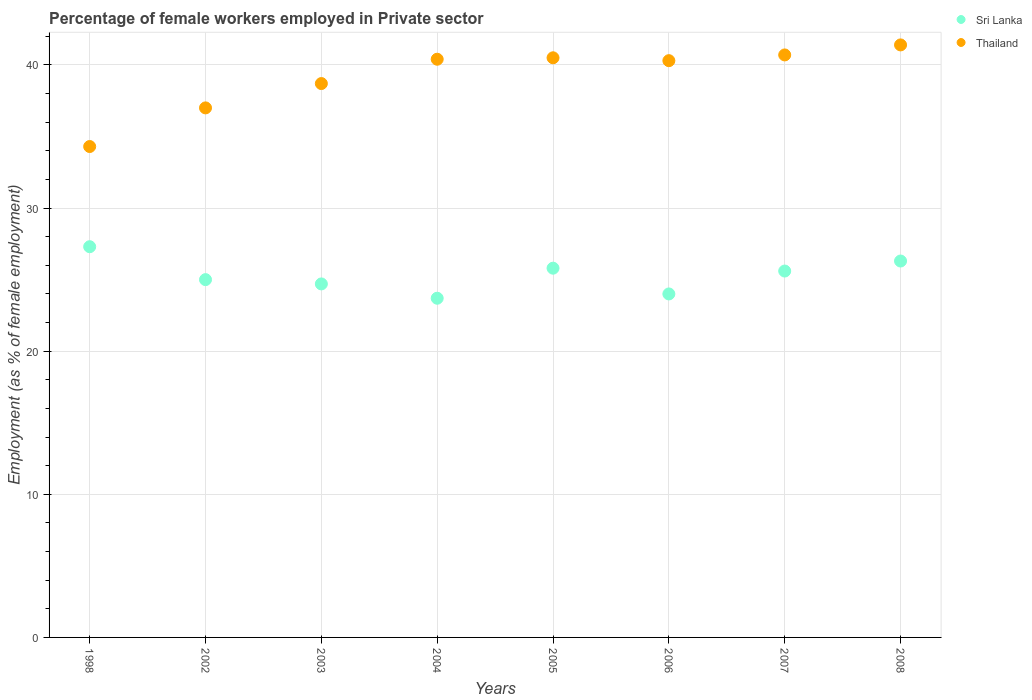What is the percentage of females employed in Private sector in Thailand in 2007?
Your response must be concise. 40.7. Across all years, what is the maximum percentage of females employed in Private sector in Sri Lanka?
Your answer should be compact. 27.3. Across all years, what is the minimum percentage of females employed in Private sector in Sri Lanka?
Your response must be concise. 23.7. In which year was the percentage of females employed in Private sector in Sri Lanka maximum?
Make the answer very short. 1998. What is the total percentage of females employed in Private sector in Sri Lanka in the graph?
Provide a short and direct response. 202.4. What is the difference between the percentage of females employed in Private sector in Thailand in 2006 and the percentage of females employed in Private sector in Sri Lanka in 2004?
Keep it short and to the point. 16.6. What is the average percentage of females employed in Private sector in Thailand per year?
Your response must be concise. 39.16. In the year 2006, what is the difference between the percentage of females employed in Private sector in Thailand and percentage of females employed in Private sector in Sri Lanka?
Ensure brevity in your answer.  16.3. In how many years, is the percentage of females employed in Private sector in Sri Lanka greater than 30 %?
Keep it short and to the point. 0. What is the ratio of the percentage of females employed in Private sector in Sri Lanka in 2002 to that in 2008?
Give a very brief answer. 0.95. Is the difference between the percentage of females employed in Private sector in Thailand in 2004 and 2008 greater than the difference between the percentage of females employed in Private sector in Sri Lanka in 2004 and 2008?
Your answer should be very brief. Yes. What is the difference between the highest and the second highest percentage of females employed in Private sector in Thailand?
Offer a terse response. 0.7. What is the difference between the highest and the lowest percentage of females employed in Private sector in Thailand?
Offer a very short reply. 7.1. In how many years, is the percentage of females employed in Private sector in Sri Lanka greater than the average percentage of females employed in Private sector in Sri Lanka taken over all years?
Your answer should be compact. 4. Is the sum of the percentage of females employed in Private sector in Thailand in 2005 and 2008 greater than the maximum percentage of females employed in Private sector in Sri Lanka across all years?
Offer a terse response. Yes. Is the percentage of females employed in Private sector in Sri Lanka strictly less than the percentage of females employed in Private sector in Thailand over the years?
Your response must be concise. Yes. What is the difference between two consecutive major ticks on the Y-axis?
Keep it short and to the point. 10. Are the values on the major ticks of Y-axis written in scientific E-notation?
Provide a succinct answer. No. Does the graph contain any zero values?
Offer a terse response. No. Does the graph contain grids?
Provide a succinct answer. Yes. How many legend labels are there?
Give a very brief answer. 2. How are the legend labels stacked?
Your answer should be very brief. Vertical. What is the title of the graph?
Your answer should be compact. Percentage of female workers employed in Private sector. Does "Zambia" appear as one of the legend labels in the graph?
Give a very brief answer. No. What is the label or title of the Y-axis?
Ensure brevity in your answer.  Employment (as % of female employment). What is the Employment (as % of female employment) of Sri Lanka in 1998?
Your answer should be compact. 27.3. What is the Employment (as % of female employment) in Thailand in 1998?
Your answer should be compact. 34.3. What is the Employment (as % of female employment) in Sri Lanka in 2003?
Your answer should be compact. 24.7. What is the Employment (as % of female employment) of Thailand in 2003?
Your response must be concise. 38.7. What is the Employment (as % of female employment) of Sri Lanka in 2004?
Provide a succinct answer. 23.7. What is the Employment (as % of female employment) in Thailand in 2004?
Your answer should be compact. 40.4. What is the Employment (as % of female employment) of Sri Lanka in 2005?
Ensure brevity in your answer.  25.8. What is the Employment (as % of female employment) in Thailand in 2005?
Make the answer very short. 40.5. What is the Employment (as % of female employment) of Thailand in 2006?
Offer a terse response. 40.3. What is the Employment (as % of female employment) in Sri Lanka in 2007?
Provide a short and direct response. 25.6. What is the Employment (as % of female employment) in Thailand in 2007?
Provide a succinct answer. 40.7. What is the Employment (as % of female employment) of Sri Lanka in 2008?
Offer a very short reply. 26.3. What is the Employment (as % of female employment) of Thailand in 2008?
Keep it short and to the point. 41.4. Across all years, what is the maximum Employment (as % of female employment) in Sri Lanka?
Your answer should be very brief. 27.3. Across all years, what is the maximum Employment (as % of female employment) of Thailand?
Ensure brevity in your answer.  41.4. Across all years, what is the minimum Employment (as % of female employment) of Sri Lanka?
Ensure brevity in your answer.  23.7. Across all years, what is the minimum Employment (as % of female employment) of Thailand?
Keep it short and to the point. 34.3. What is the total Employment (as % of female employment) in Sri Lanka in the graph?
Keep it short and to the point. 202.4. What is the total Employment (as % of female employment) of Thailand in the graph?
Ensure brevity in your answer.  313.3. What is the difference between the Employment (as % of female employment) in Sri Lanka in 1998 and that in 2004?
Offer a terse response. 3.6. What is the difference between the Employment (as % of female employment) of Thailand in 1998 and that in 2005?
Offer a very short reply. -6.2. What is the difference between the Employment (as % of female employment) in Sri Lanka in 1998 and that in 2006?
Make the answer very short. 3.3. What is the difference between the Employment (as % of female employment) of Thailand in 1998 and that in 2006?
Offer a very short reply. -6. What is the difference between the Employment (as % of female employment) in Sri Lanka in 1998 and that in 2007?
Make the answer very short. 1.7. What is the difference between the Employment (as % of female employment) in Thailand in 1998 and that in 2007?
Provide a succinct answer. -6.4. What is the difference between the Employment (as % of female employment) of Thailand in 1998 and that in 2008?
Give a very brief answer. -7.1. What is the difference between the Employment (as % of female employment) in Sri Lanka in 2002 and that in 2003?
Offer a very short reply. 0.3. What is the difference between the Employment (as % of female employment) in Thailand in 2002 and that in 2004?
Your answer should be compact. -3.4. What is the difference between the Employment (as % of female employment) of Sri Lanka in 2002 and that in 2006?
Keep it short and to the point. 1. What is the difference between the Employment (as % of female employment) of Thailand in 2002 and that in 2006?
Your answer should be very brief. -3.3. What is the difference between the Employment (as % of female employment) of Thailand in 2002 and that in 2007?
Offer a very short reply. -3.7. What is the difference between the Employment (as % of female employment) of Thailand in 2002 and that in 2008?
Make the answer very short. -4.4. What is the difference between the Employment (as % of female employment) of Sri Lanka in 2003 and that in 2004?
Make the answer very short. 1. What is the difference between the Employment (as % of female employment) in Sri Lanka in 2003 and that in 2006?
Offer a very short reply. 0.7. What is the difference between the Employment (as % of female employment) of Sri Lanka in 2003 and that in 2007?
Offer a very short reply. -0.9. What is the difference between the Employment (as % of female employment) of Thailand in 2003 and that in 2008?
Ensure brevity in your answer.  -2.7. What is the difference between the Employment (as % of female employment) of Sri Lanka in 2004 and that in 2005?
Your response must be concise. -2.1. What is the difference between the Employment (as % of female employment) of Thailand in 2004 and that in 2005?
Ensure brevity in your answer.  -0.1. What is the difference between the Employment (as % of female employment) in Thailand in 2004 and that in 2006?
Offer a terse response. 0.1. What is the difference between the Employment (as % of female employment) of Thailand in 2005 and that in 2006?
Keep it short and to the point. 0.2. What is the difference between the Employment (as % of female employment) of Sri Lanka in 2005 and that in 2007?
Make the answer very short. 0.2. What is the difference between the Employment (as % of female employment) of Sri Lanka in 2005 and that in 2008?
Your answer should be very brief. -0.5. What is the difference between the Employment (as % of female employment) in Thailand in 2005 and that in 2008?
Provide a short and direct response. -0.9. What is the difference between the Employment (as % of female employment) in Thailand in 2006 and that in 2007?
Your answer should be compact. -0.4. What is the difference between the Employment (as % of female employment) of Sri Lanka in 1998 and the Employment (as % of female employment) of Thailand in 2002?
Provide a short and direct response. -9.7. What is the difference between the Employment (as % of female employment) in Sri Lanka in 1998 and the Employment (as % of female employment) in Thailand in 2003?
Offer a very short reply. -11.4. What is the difference between the Employment (as % of female employment) in Sri Lanka in 1998 and the Employment (as % of female employment) in Thailand in 2004?
Keep it short and to the point. -13.1. What is the difference between the Employment (as % of female employment) of Sri Lanka in 1998 and the Employment (as % of female employment) of Thailand in 2008?
Provide a succinct answer. -14.1. What is the difference between the Employment (as % of female employment) in Sri Lanka in 2002 and the Employment (as % of female employment) in Thailand in 2003?
Keep it short and to the point. -13.7. What is the difference between the Employment (as % of female employment) of Sri Lanka in 2002 and the Employment (as % of female employment) of Thailand in 2004?
Provide a succinct answer. -15.4. What is the difference between the Employment (as % of female employment) of Sri Lanka in 2002 and the Employment (as % of female employment) of Thailand in 2005?
Ensure brevity in your answer.  -15.5. What is the difference between the Employment (as % of female employment) in Sri Lanka in 2002 and the Employment (as % of female employment) in Thailand in 2006?
Offer a very short reply. -15.3. What is the difference between the Employment (as % of female employment) in Sri Lanka in 2002 and the Employment (as % of female employment) in Thailand in 2007?
Ensure brevity in your answer.  -15.7. What is the difference between the Employment (as % of female employment) in Sri Lanka in 2002 and the Employment (as % of female employment) in Thailand in 2008?
Provide a succinct answer. -16.4. What is the difference between the Employment (as % of female employment) in Sri Lanka in 2003 and the Employment (as % of female employment) in Thailand in 2004?
Your answer should be compact. -15.7. What is the difference between the Employment (as % of female employment) in Sri Lanka in 2003 and the Employment (as % of female employment) in Thailand in 2005?
Your answer should be compact. -15.8. What is the difference between the Employment (as % of female employment) of Sri Lanka in 2003 and the Employment (as % of female employment) of Thailand in 2006?
Make the answer very short. -15.6. What is the difference between the Employment (as % of female employment) of Sri Lanka in 2003 and the Employment (as % of female employment) of Thailand in 2008?
Offer a very short reply. -16.7. What is the difference between the Employment (as % of female employment) of Sri Lanka in 2004 and the Employment (as % of female employment) of Thailand in 2005?
Provide a succinct answer. -16.8. What is the difference between the Employment (as % of female employment) in Sri Lanka in 2004 and the Employment (as % of female employment) in Thailand in 2006?
Your response must be concise. -16.6. What is the difference between the Employment (as % of female employment) of Sri Lanka in 2004 and the Employment (as % of female employment) of Thailand in 2008?
Offer a very short reply. -17.7. What is the difference between the Employment (as % of female employment) in Sri Lanka in 2005 and the Employment (as % of female employment) in Thailand in 2006?
Your answer should be very brief. -14.5. What is the difference between the Employment (as % of female employment) in Sri Lanka in 2005 and the Employment (as % of female employment) in Thailand in 2007?
Provide a succinct answer. -14.9. What is the difference between the Employment (as % of female employment) in Sri Lanka in 2005 and the Employment (as % of female employment) in Thailand in 2008?
Provide a succinct answer. -15.6. What is the difference between the Employment (as % of female employment) of Sri Lanka in 2006 and the Employment (as % of female employment) of Thailand in 2007?
Make the answer very short. -16.7. What is the difference between the Employment (as % of female employment) in Sri Lanka in 2006 and the Employment (as % of female employment) in Thailand in 2008?
Make the answer very short. -17.4. What is the difference between the Employment (as % of female employment) of Sri Lanka in 2007 and the Employment (as % of female employment) of Thailand in 2008?
Your answer should be compact. -15.8. What is the average Employment (as % of female employment) in Sri Lanka per year?
Provide a succinct answer. 25.3. What is the average Employment (as % of female employment) of Thailand per year?
Offer a terse response. 39.16. In the year 1998, what is the difference between the Employment (as % of female employment) of Sri Lanka and Employment (as % of female employment) of Thailand?
Your answer should be very brief. -7. In the year 2002, what is the difference between the Employment (as % of female employment) in Sri Lanka and Employment (as % of female employment) in Thailand?
Give a very brief answer. -12. In the year 2004, what is the difference between the Employment (as % of female employment) of Sri Lanka and Employment (as % of female employment) of Thailand?
Ensure brevity in your answer.  -16.7. In the year 2005, what is the difference between the Employment (as % of female employment) in Sri Lanka and Employment (as % of female employment) in Thailand?
Your response must be concise. -14.7. In the year 2006, what is the difference between the Employment (as % of female employment) of Sri Lanka and Employment (as % of female employment) of Thailand?
Ensure brevity in your answer.  -16.3. In the year 2007, what is the difference between the Employment (as % of female employment) of Sri Lanka and Employment (as % of female employment) of Thailand?
Your response must be concise. -15.1. In the year 2008, what is the difference between the Employment (as % of female employment) in Sri Lanka and Employment (as % of female employment) in Thailand?
Make the answer very short. -15.1. What is the ratio of the Employment (as % of female employment) of Sri Lanka in 1998 to that in 2002?
Keep it short and to the point. 1.09. What is the ratio of the Employment (as % of female employment) in Thailand in 1998 to that in 2002?
Your response must be concise. 0.93. What is the ratio of the Employment (as % of female employment) in Sri Lanka in 1998 to that in 2003?
Keep it short and to the point. 1.11. What is the ratio of the Employment (as % of female employment) of Thailand in 1998 to that in 2003?
Ensure brevity in your answer.  0.89. What is the ratio of the Employment (as % of female employment) in Sri Lanka in 1998 to that in 2004?
Offer a terse response. 1.15. What is the ratio of the Employment (as % of female employment) in Thailand in 1998 to that in 2004?
Make the answer very short. 0.85. What is the ratio of the Employment (as % of female employment) of Sri Lanka in 1998 to that in 2005?
Keep it short and to the point. 1.06. What is the ratio of the Employment (as % of female employment) in Thailand in 1998 to that in 2005?
Ensure brevity in your answer.  0.85. What is the ratio of the Employment (as % of female employment) in Sri Lanka in 1998 to that in 2006?
Ensure brevity in your answer.  1.14. What is the ratio of the Employment (as % of female employment) of Thailand in 1998 to that in 2006?
Give a very brief answer. 0.85. What is the ratio of the Employment (as % of female employment) in Sri Lanka in 1998 to that in 2007?
Ensure brevity in your answer.  1.07. What is the ratio of the Employment (as % of female employment) of Thailand in 1998 to that in 2007?
Your response must be concise. 0.84. What is the ratio of the Employment (as % of female employment) in Sri Lanka in 1998 to that in 2008?
Give a very brief answer. 1.04. What is the ratio of the Employment (as % of female employment) in Thailand in 1998 to that in 2008?
Your answer should be compact. 0.83. What is the ratio of the Employment (as % of female employment) of Sri Lanka in 2002 to that in 2003?
Give a very brief answer. 1.01. What is the ratio of the Employment (as % of female employment) of Thailand in 2002 to that in 2003?
Give a very brief answer. 0.96. What is the ratio of the Employment (as % of female employment) in Sri Lanka in 2002 to that in 2004?
Offer a terse response. 1.05. What is the ratio of the Employment (as % of female employment) of Thailand in 2002 to that in 2004?
Your response must be concise. 0.92. What is the ratio of the Employment (as % of female employment) of Thailand in 2002 to that in 2005?
Make the answer very short. 0.91. What is the ratio of the Employment (as % of female employment) of Sri Lanka in 2002 to that in 2006?
Make the answer very short. 1.04. What is the ratio of the Employment (as % of female employment) of Thailand in 2002 to that in 2006?
Your response must be concise. 0.92. What is the ratio of the Employment (as % of female employment) in Sri Lanka in 2002 to that in 2007?
Offer a very short reply. 0.98. What is the ratio of the Employment (as % of female employment) in Sri Lanka in 2002 to that in 2008?
Provide a succinct answer. 0.95. What is the ratio of the Employment (as % of female employment) in Thailand in 2002 to that in 2008?
Provide a succinct answer. 0.89. What is the ratio of the Employment (as % of female employment) in Sri Lanka in 2003 to that in 2004?
Ensure brevity in your answer.  1.04. What is the ratio of the Employment (as % of female employment) of Thailand in 2003 to that in 2004?
Offer a terse response. 0.96. What is the ratio of the Employment (as % of female employment) of Sri Lanka in 2003 to that in 2005?
Provide a succinct answer. 0.96. What is the ratio of the Employment (as % of female employment) of Thailand in 2003 to that in 2005?
Your answer should be compact. 0.96. What is the ratio of the Employment (as % of female employment) in Sri Lanka in 2003 to that in 2006?
Give a very brief answer. 1.03. What is the ratio of the Employment (as % of female employment) in Thailand in 2003 to that in 2006?
Your response must be concise. 0.96. What is the ratio of the Employment (as % of female employment) in Sri Lanka in 2003 to that in 2007?
Your response must be concise. 0.96. What is the ratio of the Employment (as % of female employment) of Thailand in 2003 to that in 2007?
Provide a short and direct response. 0.95. What is the ratio of the Employment (as % of female employment) of Sri Lanka in 2003 to that in 2008?
Provide a short and direct response. 0.94. What is the ratio of the Employment (as % of female employment) in Thailand in 2003 to that in 2008?
Offer a very short reply. 0.93. What is the ratio of the Employment (as % of female employment) of Sri Lanka in 2004 to that in 2005?
Provide a short and direct response. 0.92. What is the ratio of the Employment (as % of female employment) of Thailand in 2004 to that in 2005?
Keep it short and to the point. 1. What is the ratio of the Employment (as % of female employment) of Sri Lanka in 2004 to that in 2006?
Keep it short and to the point. 0.99. What is the ratio of the Employment (as % of female employment) of Sri Lanka in 2004 to that in 2007?
Provide a succinct answer. 0.93. What is the ratio of the Employment (as % of female employment) in Sri Lanka in 2004 to that in 2008?
Offer a very short reply. 0.9. What is the ratio of the Employment (as % of female employment) in Thailand in 2004 to that in 2008?
Your answer should be very brief. 0.98. What is the ratio of the Employment (as % of female employment) in Sri Lanka in 2005 to that in 2006?
Provide a succinct answer. 1.07. What is the ratio of the Employment (as % of female employment) in Thailand in 2005 to that in 2006?
Ensure brevity in your answer.  1. What is the ratio of the Employment (as % of female employment) of Sri Lanka in 2005 to that in 2007?
Keep it short and to the point. 1.01. What is the ratio of the Employment (as % of female employment) in Thailand in 2005 to that in 2007?
Your answer should be very brief. 1. What is the ratio of the Employment (as % of female employment) in Sri Lanka in 2005 to that in 2008?
Your answer should be very brief. 0.98. What is the ratio of the Employment (as % of female employment) in Thailand in 2005 to that in 2008?
Offer a very short reply. 0.98. What is the ratio of the Employment (as % of female employment) in Thailand in 2006 to that in 2007?
Provide a short and direct response. 0.99. What is the ratio of the Employment (as % of female employment) in Sri Lanka in 2006 to that in 2008?
Ensure brevity in your answer.  0.91. What is the ratio of the Employment (as % of female employment) in Thailand in 2006 to that in 2008?
Ensure brevity in your answer.  0.97. What is the ratio of the Employment (as % of female employment) of Sri Lanka in 2007 to that in 2008?
Offer a very short reply. 0.97. What is the ratio of the Employment (as % of female employment) in Thailand in 2007 to that in 2008?
Your response must be concise. 0.98. What is the difference between the highest and the second highest Employment (as % of female employment) in Thailand?
Keep it short and to the point. 0.7. 